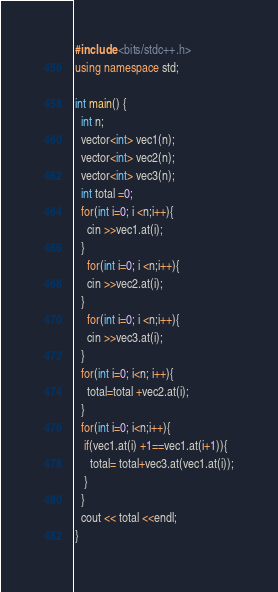Convert code to text. <code><loc_0><loc_0><loc_500><loc_500><_C++_>#include <bits/stdc++.h>
using namespace std;

int main() {
  int n;
  vector<int> vec1(n);
  vector<int> vec2(n);
  vector<int> vec3(n);
  int total =0;
  for(int i=0; i <n;i++){
    cin >>vec1.at(i);
  }
    for(int i=0; i <n;i++){
    cin >>vec2.at(i);
  }
    for(int i=0; i <n;i++){
    cin >>vec3.at(i);
  }
  for(int i=0; i<n; i++){
    total=total +vec2.at(i);
  }
  for(int i=0; i<n;i++){
   if(vec1.at(i) +1==vec1.at(i+1)){
     total= total+vec3.at(vec1.at(i));
   }
  }
  cout << total <<endl;
}
</code> 